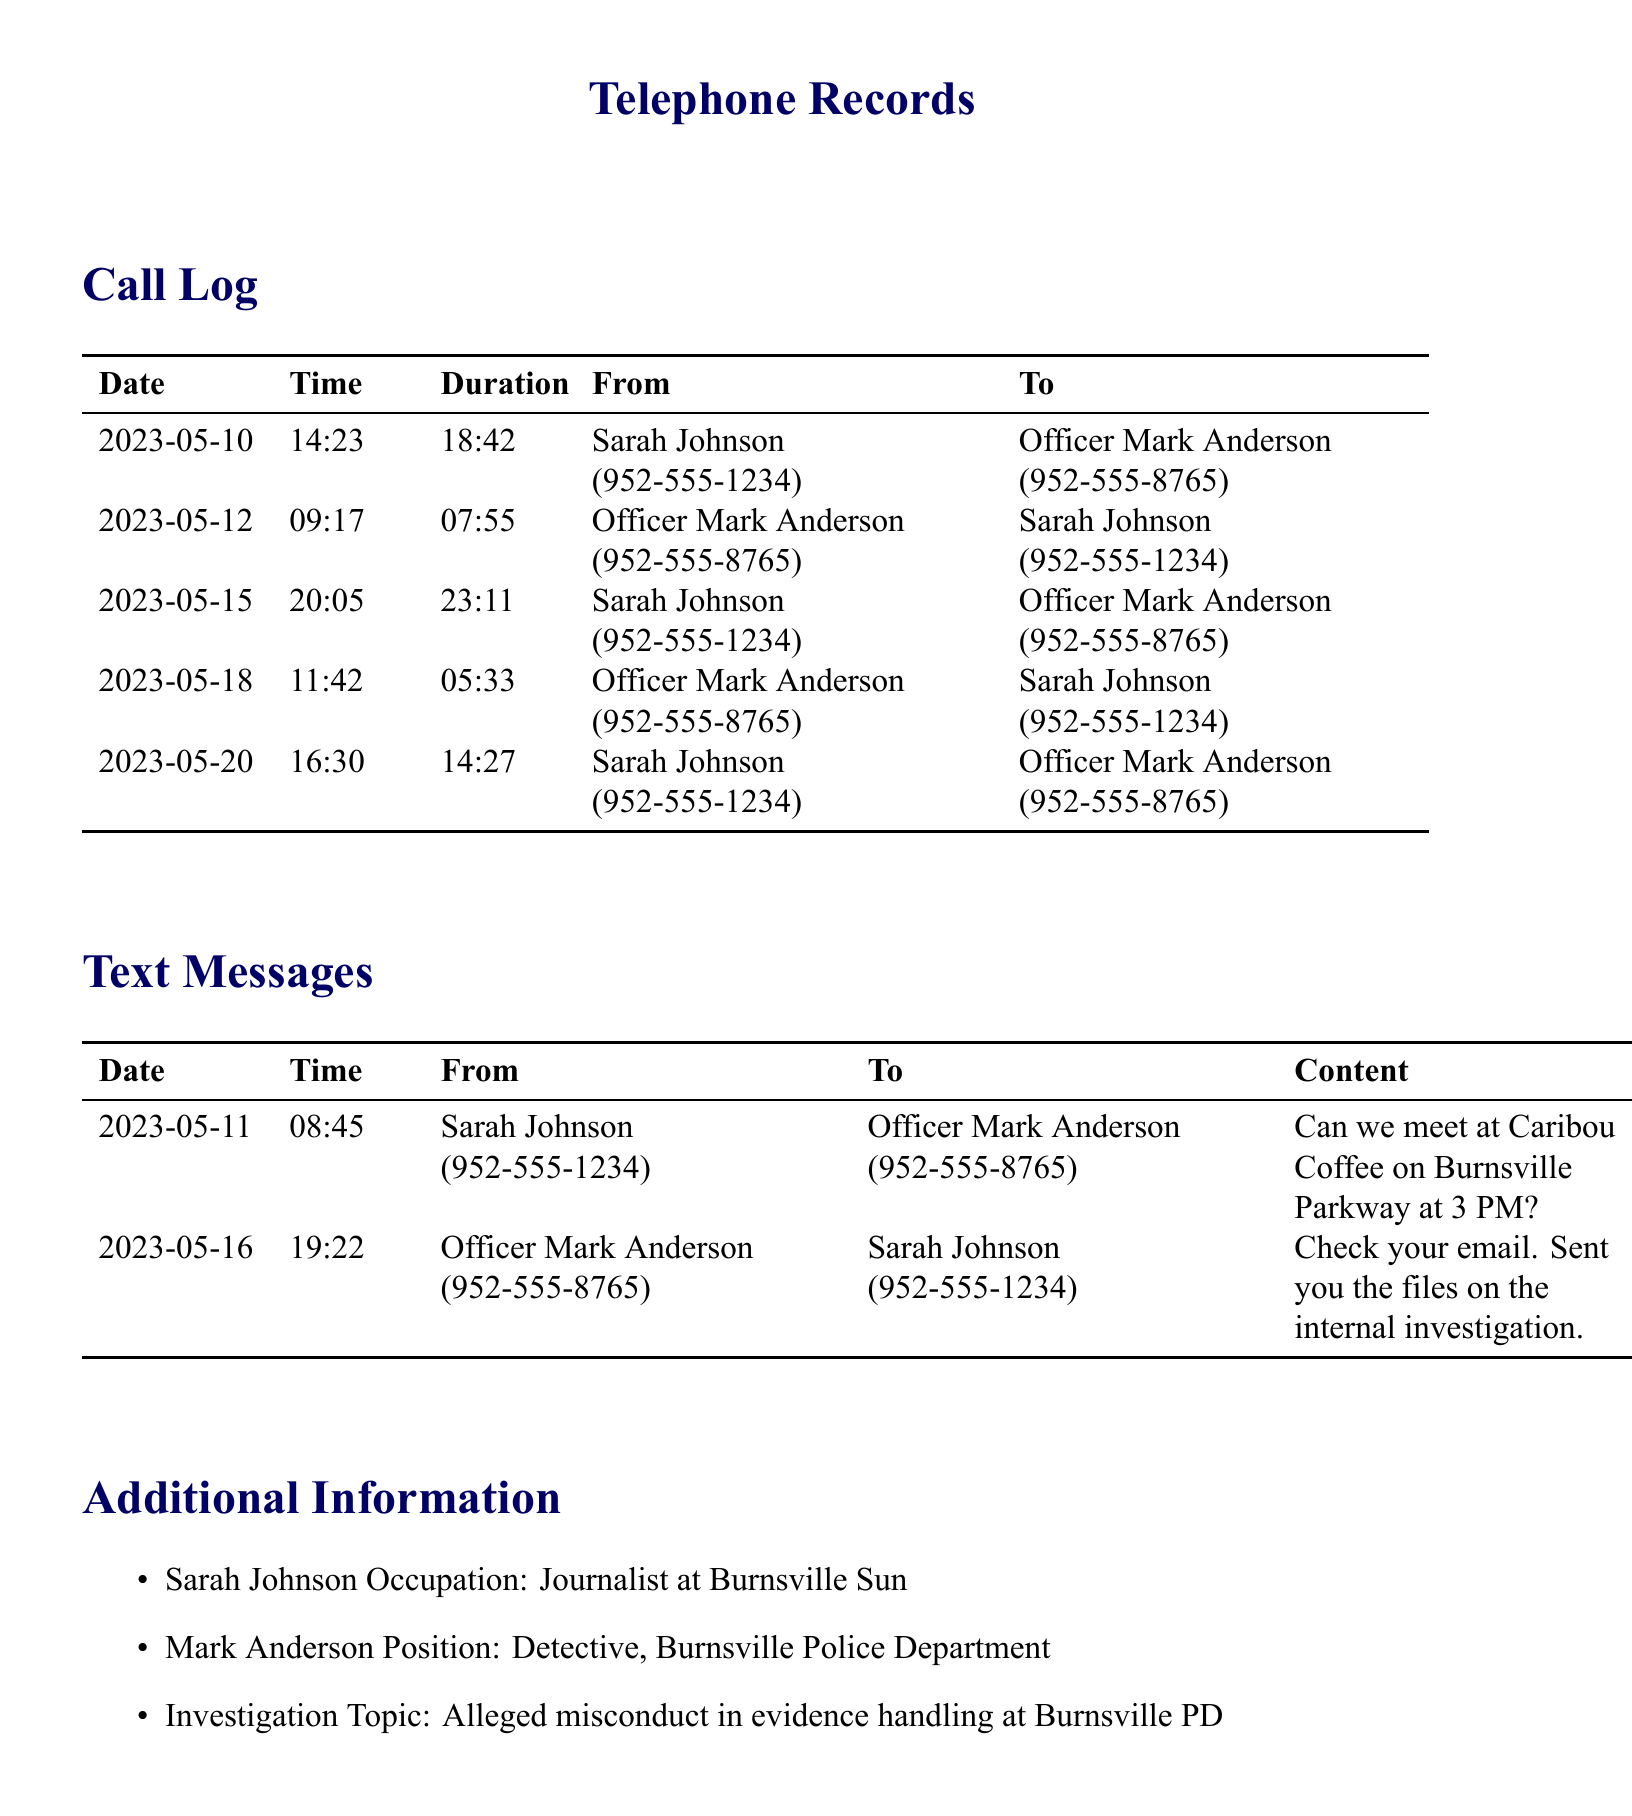what is the date of the first call? The first call is listed under the date "2023-05-10".
Answer: 2023-05-10 who is Sarah Johnson? Sarah Johnson is identified as a journalist at Burnsville Sun in the additional information section.
Answer: Journalist at Burnsville Sun how long was the longest call duration? The longest call duration can be found in the log, which is 23 minutes and 11 seconds.
Answer: 23:11 what was the content of the text message sent on May 11? The content of the text message can be found in the text message section where it asks about meeting at Caribou Coffee.
Answer: Can we meet at Caribou Coffee on Burnsville Parkway at 3 PM? how many times did Sarah Johnson call Officer Mark Anderson? The call log indicates instances of Sarah calling Officer Anderson, which totals four times.
Answer: Four times who sent the files on the internal investigation? Officer Mark Anderson sent the files, as mentioned in the text message on May 16.
Answer: Officer Mark Anderson what is the main topic of the investigation? The additional information section mentions the main topic of the investigation as alleged misconduct in evidence handling at Burnsville PD.
Answer: Alleged misconduct in evidence handling at Burnsville PD what day was the second text message sent? The second text message was sent on May 16, according to the text messages table.
Answer: 2023-05-16 how many total calls are recorded? The total number of calls recorded can be counted from the call log, which shows five calls in total.
Answer: Five calls 